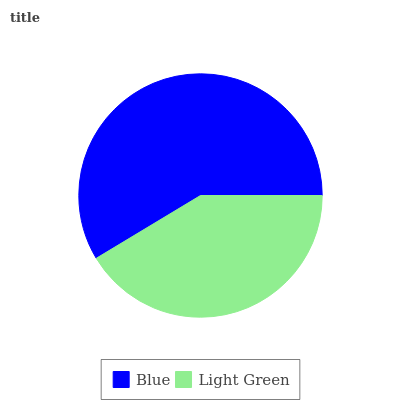Is Light Green the minimum?
Answer yes or no. Yes. Is Blue the maximum?
Answer yes or no. Yes. Is Light Green the maximum?
Answer yes or no. No. Is Blue greater than Light Green?
Answer yes or no. Yes. Is Light Green less than Blue?
Answer yes or no. Yes. Is Light Green greater than Blue?
Answer yes or no. No. Is Blue less than Light Green?
Answer yes or no. No. Is Blue the high median?
Answer yes or no. Yes. Is Light Green the low median?
Answer yes or no. Yes. Is Light Green the high median?
Answer yes or no. No. Is Blue the low median?
Answer yes or no. No. 